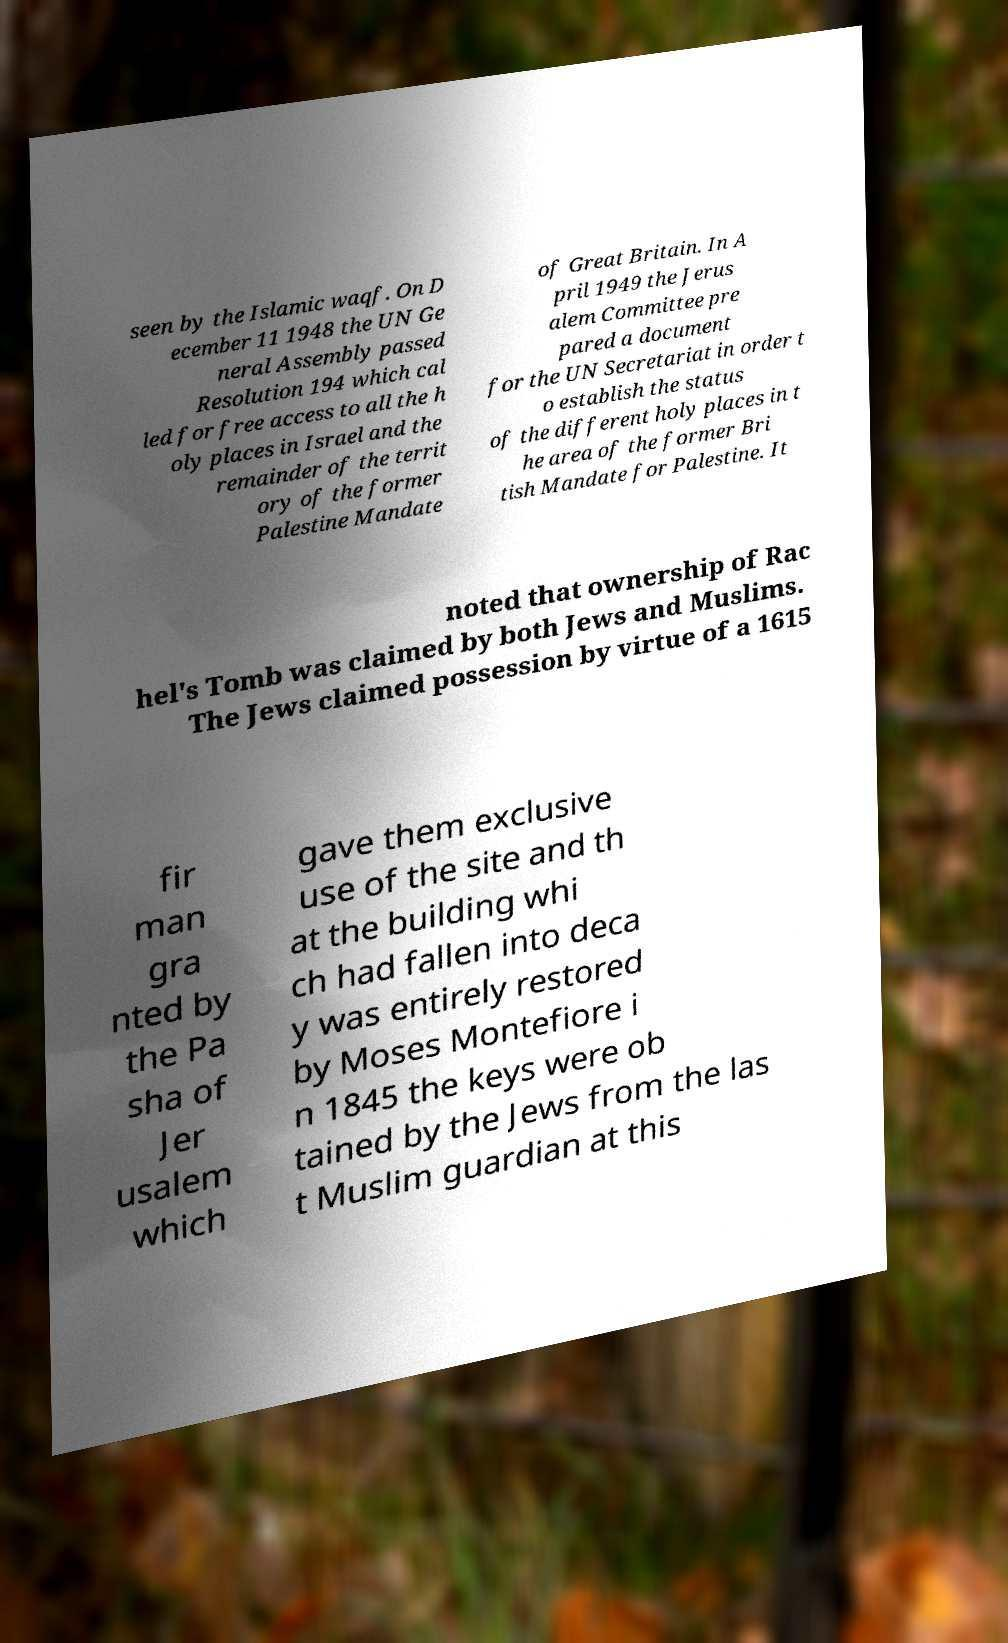Please identify and transcribe the text found in this image. seen by the Islamic waqf. On D ecember 11 1948 the UN Ge neral Assembly passed Resolution 194 which cal led for free access to all the h oly places in Israel and the remainder of the territ ory of the former Palestine Mandate of Great Britain. In A pril 1949 the Jerus alem Committee pre pared a document for the UN Secretariat in order t o establish the status of the different holy places in t he area of the former Bri tish Mandate for Palestine. It noted that ownership of Rac hel's Tomb was claimed by both Jews and Muslims. The Jews claimed possession by virtue of a 1615 fir man gra nted by the Pa sha of Jer usalem which gave them exclusive use of the site and th at the building whi ch had fallen into deca y was entirely restored by Moses Montefiore i n 1845 the keys were ob tained by the Jews from the las t Muslim guardian at this 